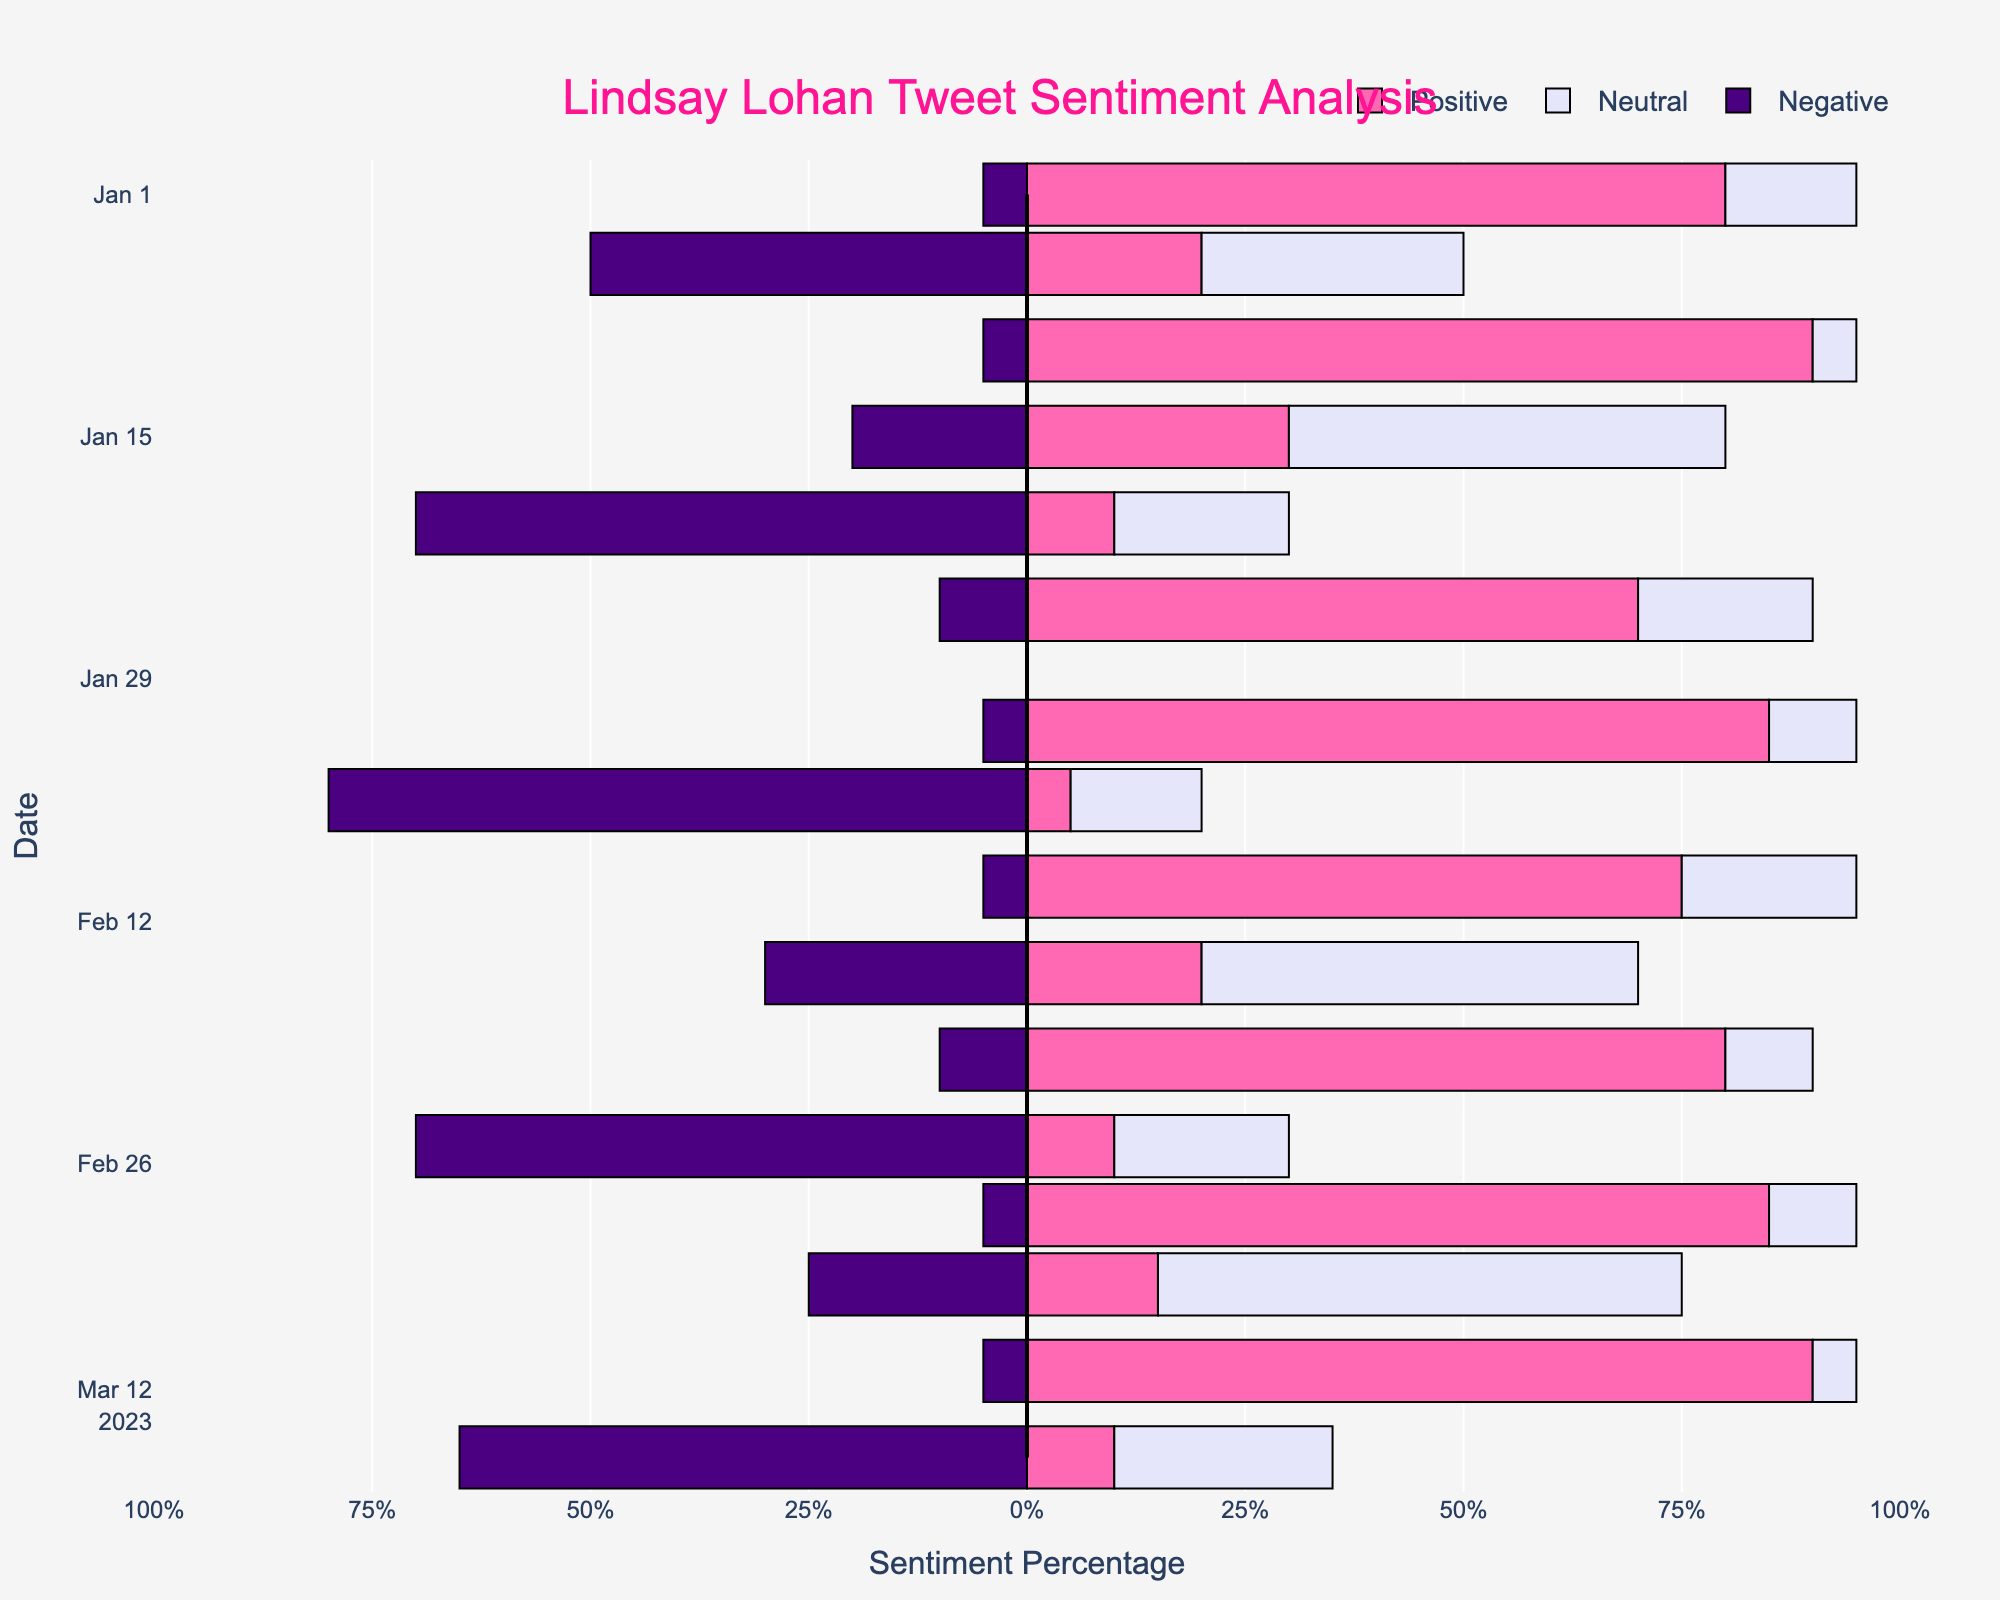What date has the highest percentage of positive tweets? To find this, we look for the longest red bar (representing positive sentiment) in the chart. The longest red bar corresponds to January 10, 2023.
Answer: January 10, 2023 On February 25, 2023, which sentiment had the highest percentage? By examining the bars for February 25, 2023, the largest bar is the negative sentiment (blue) at 70%.
Answer: Negative On which date is the sentiment most neutral? We need to find the date where the neutral (light purple) bar is the longest. This occurs on March 5, 2023.
Answer: March 5, 2023 Compare the negative sentiment percentages on January 5 and March 15. Which date has a higher negative sentiment? Trailing the negative bars for both dates, January 5 has a bar with 50%, and March 15 shows a higher bar of 65%.
Answer: March 15 Which date shows the greatest mix of positive and neutral sentiments without any negative sentiment, and what is its total percentage? We look for a date where positive and neutral sentiments sum to 100%. January 1, 2023, has positive 80% and neutral 15%, totaling 95% with only 5% negative sentiment.
Answer: January 1, 2023 On March 1, 2023, what is the combined percentage of positive and negative sentiments? March 1 has positive at 85% and negative at 5%. So, the combined percentage is 85% + 5% = 90%.
Answer: 90% Which sentiment was highest in the tweet related to Lindsay Lohan's album on January 15, 2023? For January 15, 2023, the longest bar is the neutral sentiment at 50%.
Answer: Neutral How does the positive sentiment change from February 1 to February 10, 2023? February 1 has a positive sentiment of 85%, and February 10 has 75%. The change is 85% - 75% = -10%.
Answer: Decreases by 10% Comparing January 1 and March 10, which date has a higher positive sentiment, and by how much? January 1 has a positive sentiment of 80%, while March 10 has 90%. The comparison shows an increase of 90% - 80% = 10%.
Answer: March 10, by 10% What is the average positive sentiment for the tweets on January 1, January 10, and January 25? Adding the positive sentiments: 80% (Jan 1) + 90% (Jan 10) + 70% (Jan 25) = 240%. Dividing by 3 gives the average: 240% / 3 = 80%.
Answer: 80% 